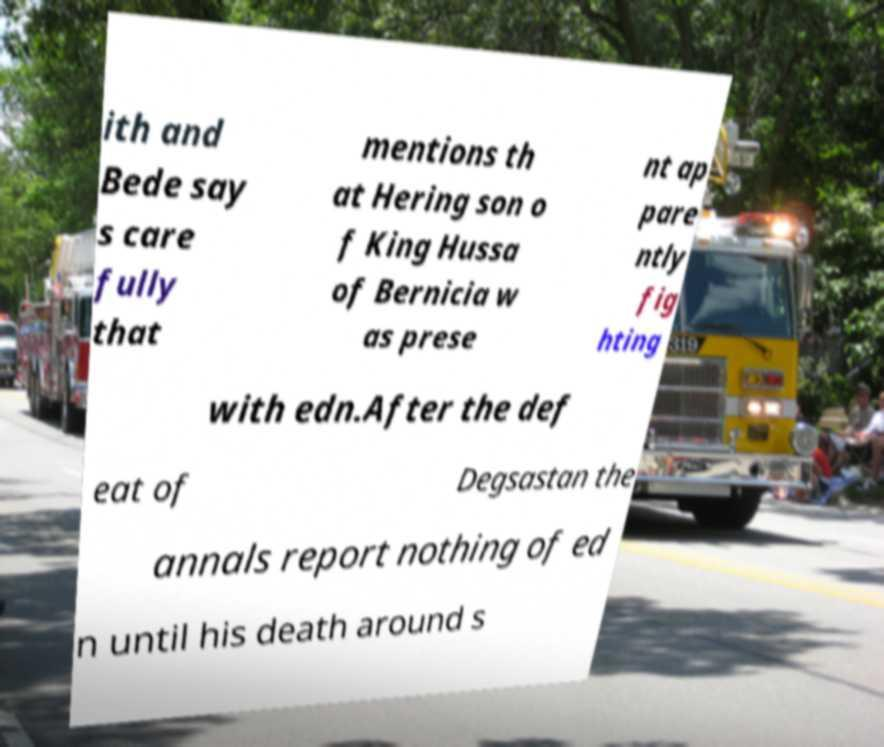Could you extract and type out the text from this image? ith and Bede say s care fully that mentions th at Hering son o f King Hussa of Bernicia w as prese nt ap pare ntly fig hting with edn.After the def eat of Degsastan the annals report nothing of ed n until his death around s 